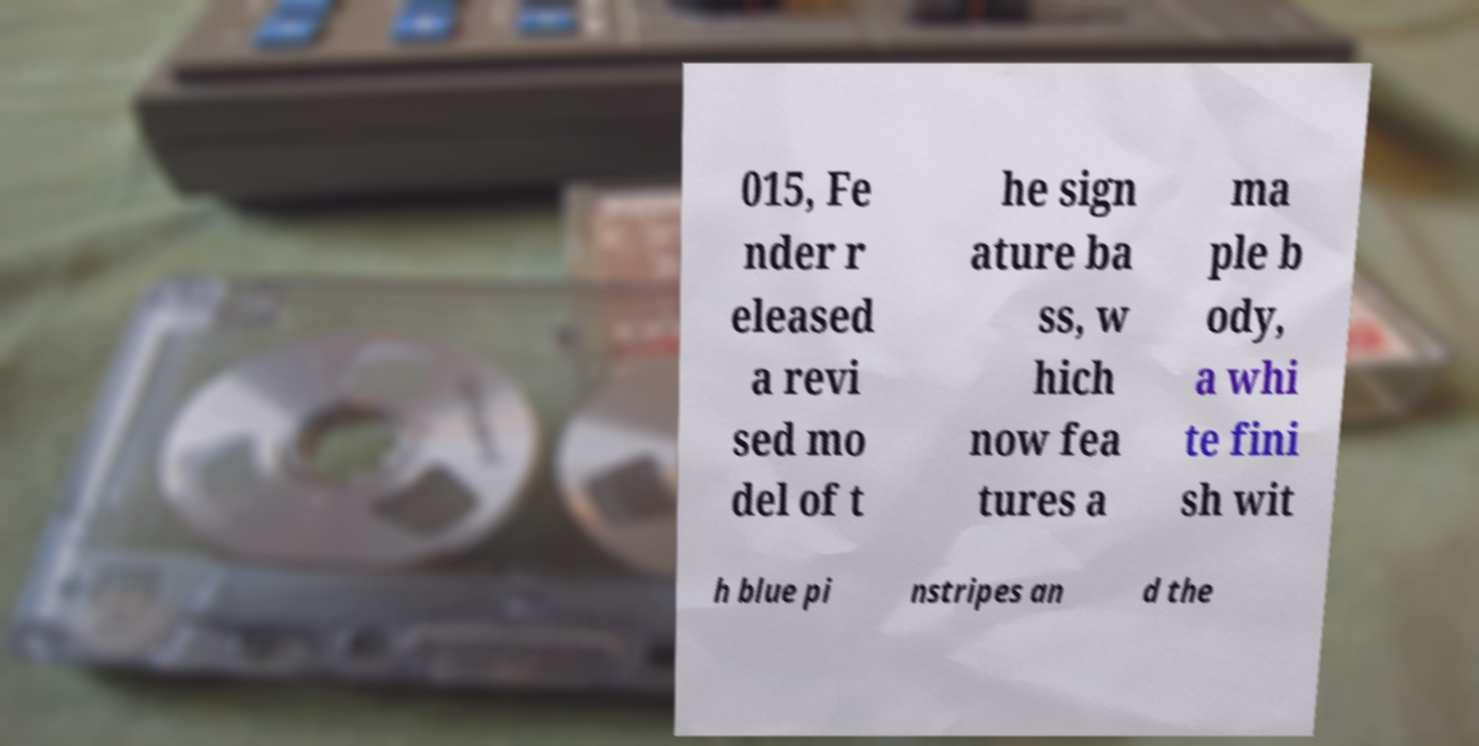Please identify and transcribe the text found in this image. 015, Fe nder r eleased a revi sed mo del of t he sign ature ba ss, w hich now fea tures a ma ple b ody, a whi te fini sh wit h blue pi nstripes an d the 